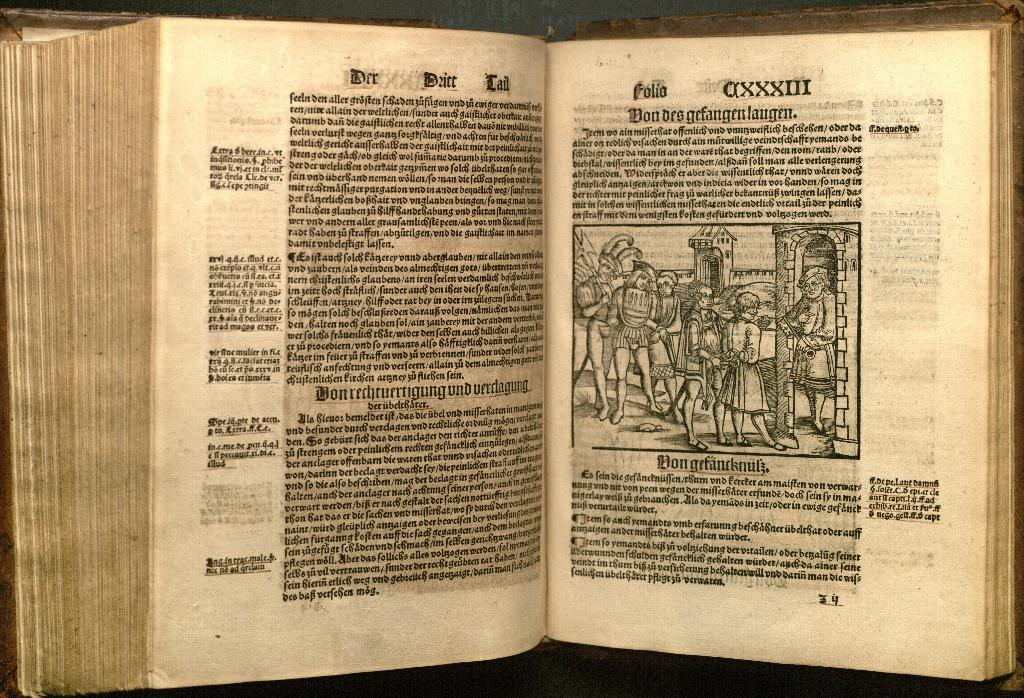<image>
Write a terse but informative summary of the picture. A book opened to a picture of Don gefancknufz. 